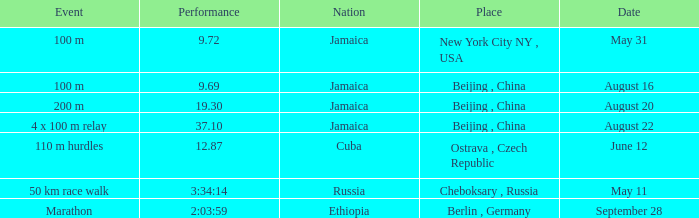69-second duration? Jamaica. 